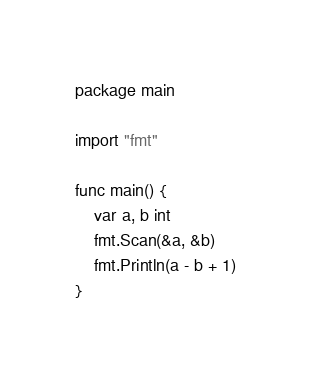<code> <loc_0><loc_0><loc_500><loc_500><_Go_>package main

import "fmt"

func main() {
	var a, b int
	fmt.Scan(&a, &b)
	fmt.Println(a - b + 1)
}
</code> 